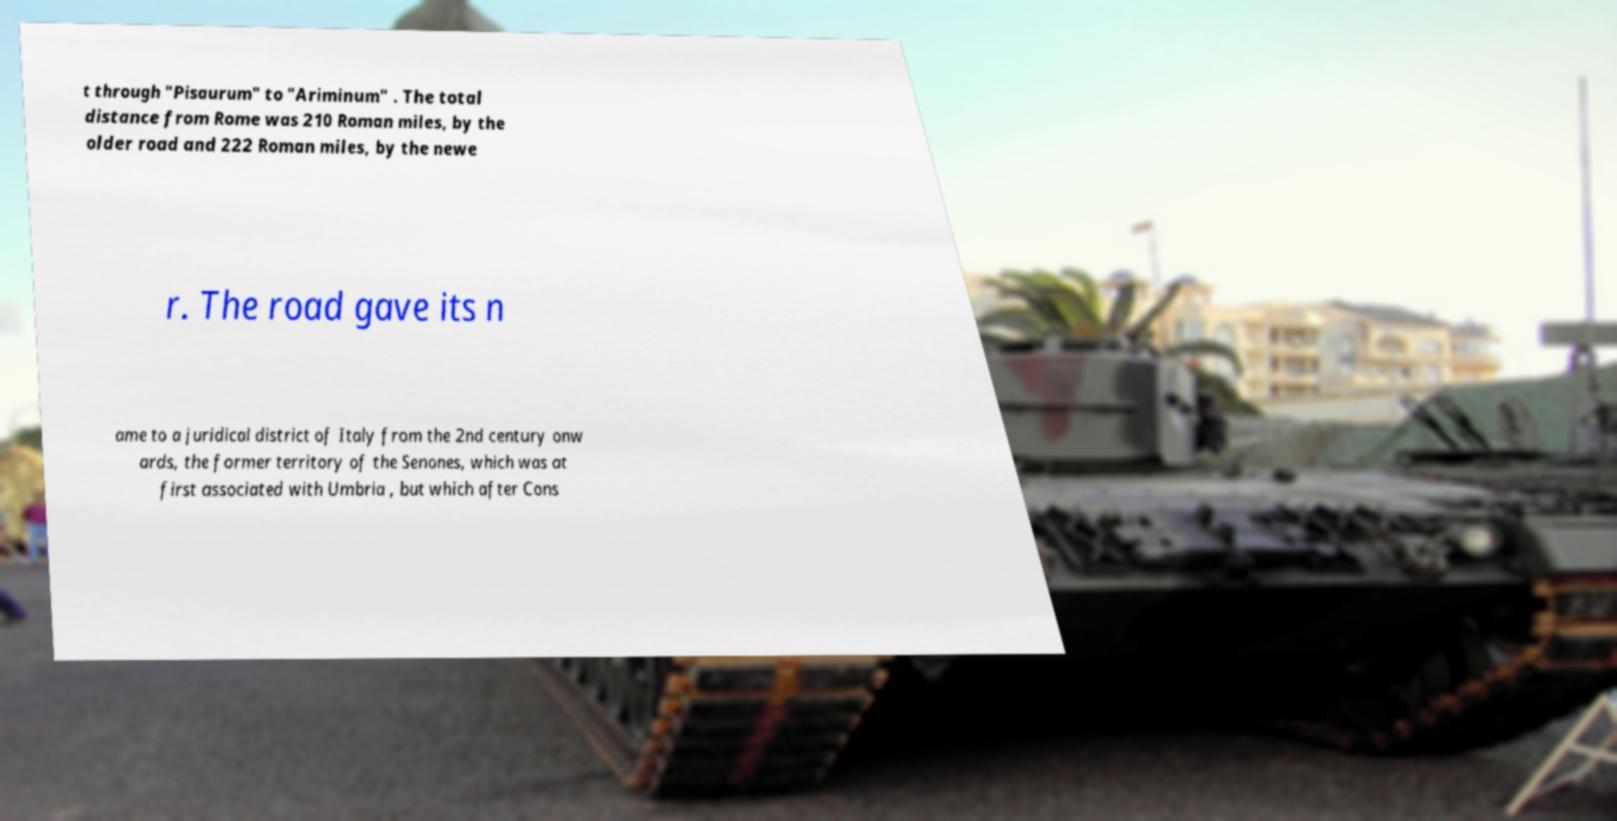Can you accurately transcribe the text from the provided image for me? t through "Pisaurum" to "Ariminum" . The total distance from Rome was 210 Roman miles, by the older road and 222 Roman miles, by the newe r. The road gave its n ame to a juridical district of Italy from the 2nd century onw ards, the former territory of the Senones, which was at first associated with Umbria , but which after Cons 